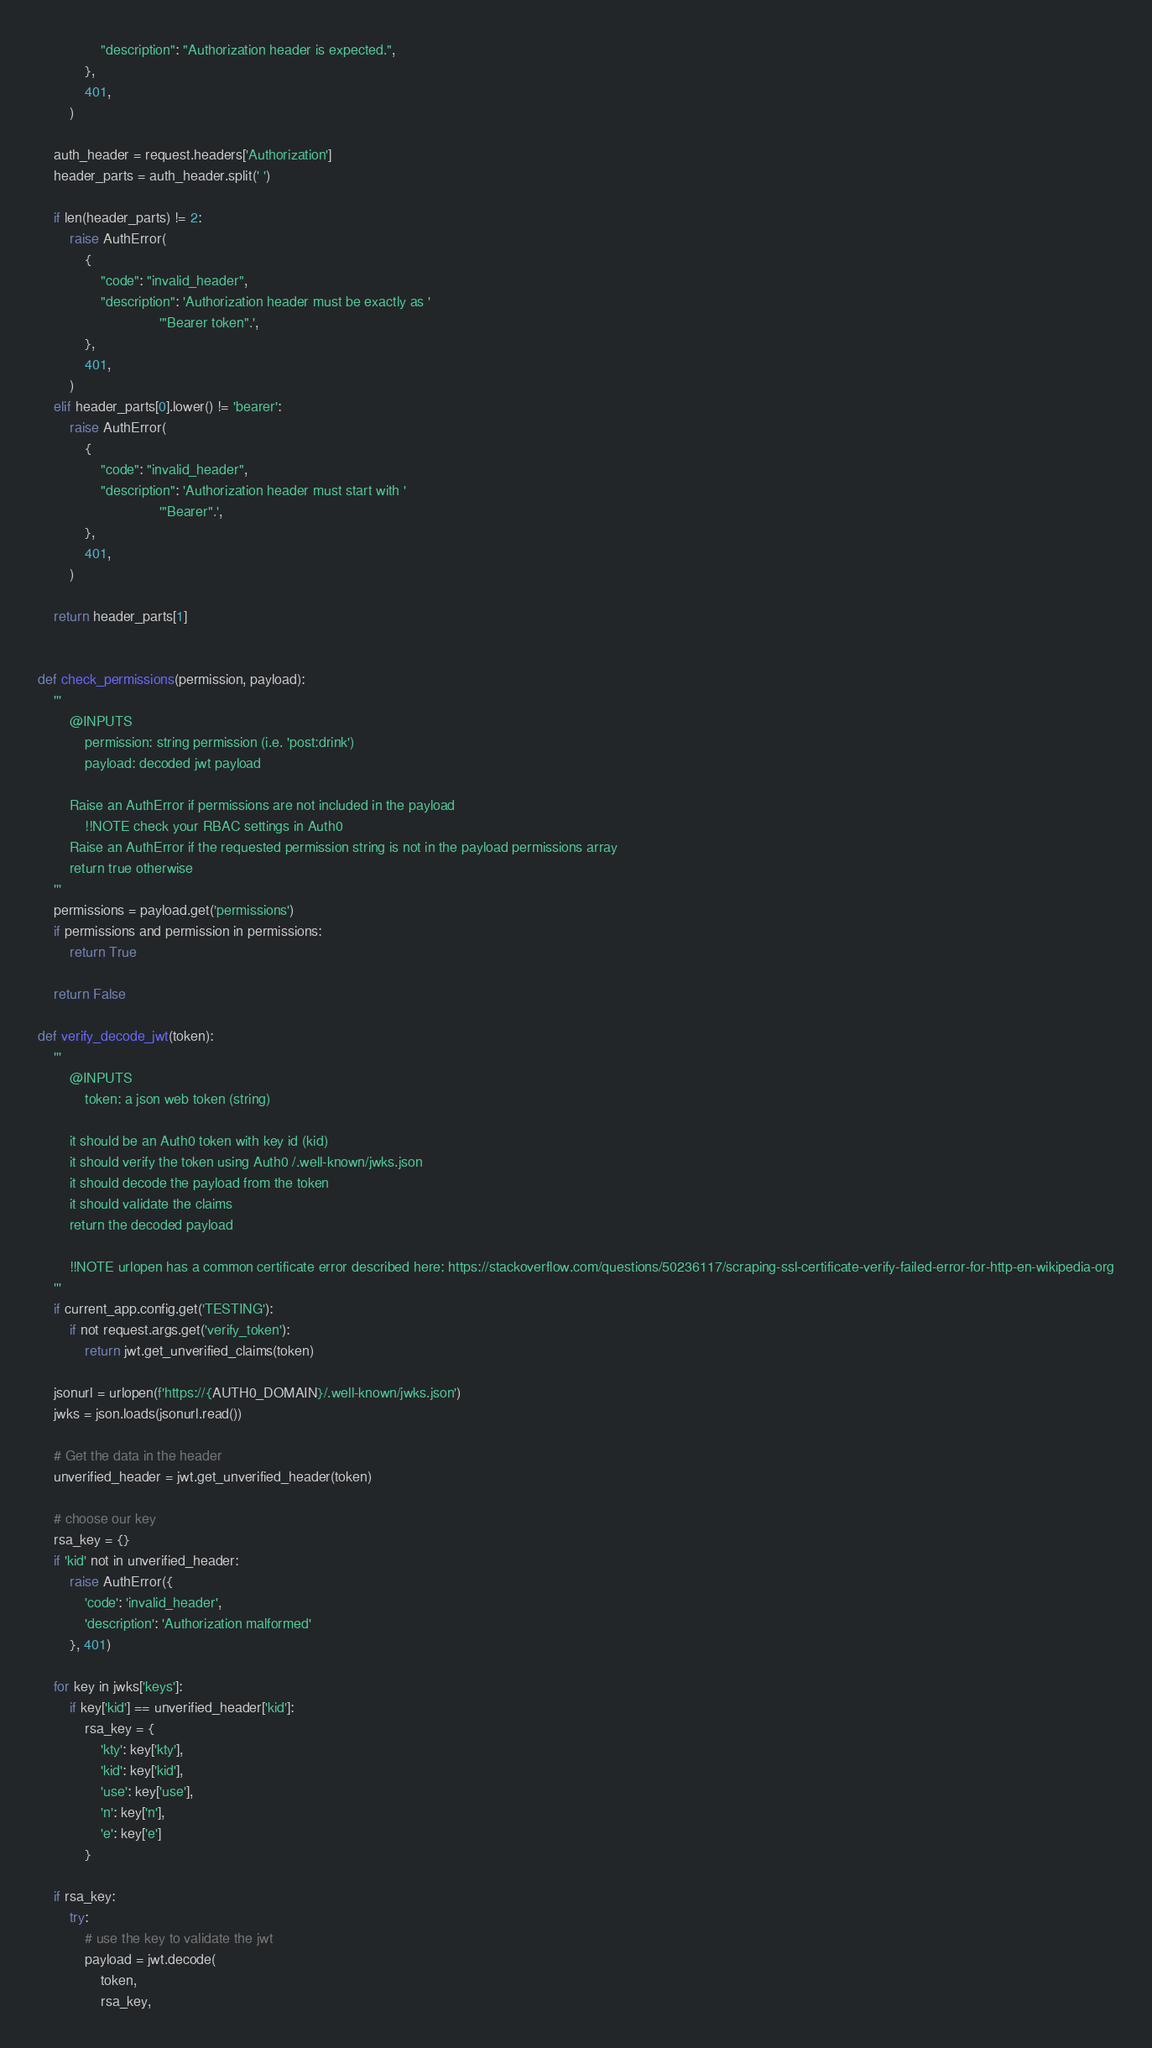<code> <loc_0><loc_0><loc_500><loc_500><_Python_>                "description": "Authorization header is expected.",
            },
            401,
        )

    auth_header = request.headers['Authorization']
    header_parts = auth_header.split(' ')

    if len(header_parts) != 2:
        raise AuthError(
            {
                "code": "invalid_header",
                "description": 'Authorization header must be exactly as '
                               '"Bearer token".',
            },
            401,
        )
    elif header_parts[0].lower() != 'bearer':
        raise AuthError(
            {
                "code": "invalid_header",
                "description": 'Authorization header must start with '
                               '"Bearer".',
            },
            401,
        )

    return header_parts[1]


def check_permissions(permission, payload):
    '''
        @INPUTS
            permission: string permission (i.e. 'post:drink')
            payload: decoded jwt payload

        Raise an AuthError if permissions are not included in the payload
            !!NOTE check your RBAC settings in Auth0
        Raise an AuthError if the requested permission string is not in the payload permissions array
        return true otherwise
    '''
    permissions = payload.get('permissions')
    if permissions and permission in permissions:
        return True

    return False

def verify_decode_jwt(token):
    '''
        @INPUTS
            token: a json web token (string)

        it should be an Auth0 token with key id (kid)
        it should verify the token using Auth0 /.well-known/jwks.json
        it should decode the payload from the token
        it should validate the claims
        return the decoded payload

        !!NOTE urlopen has a common certificate error described here: https://stackoverflow.com/questions/50236117/scraping-ssl-certificate-verify-failed-error-for-http-en-wikipedia-org
    '''
    if current_app.config.get('TESTING'):
        if not request.args.get('verify_token'):
            return jwt.get_unverified_claims(token)

    jsonurl = urlopen(f'https://{AUTH0_DOMAIN}/.well-known/jwks.json')
    jwks = json.loads(jsonurl.read())

    # Get the data in the header
    unverified_header = jwt.get_unverified_header(token)

    # choose our key
    rsa_key = {}
    if 'kid' not in unverified_header:
        raise AuthError({
            'code': 'invalid_header',
            'description': 'Authorization malformed'
        }, 401)

    for key in jwks['keys']:
        if key['kid'] == unverified_header['kid']:
            rsa_key = {
                'kty': key['kty'],
                'kid': key['kid'],
                'use': key['use'],
                'n': key['n'],
                'e': key['e']
            }

    if rsa_key:
        try:
            # use the key to validate the jwt
            payload = jwt.decode(
                token,
                rsa_key,</code> 